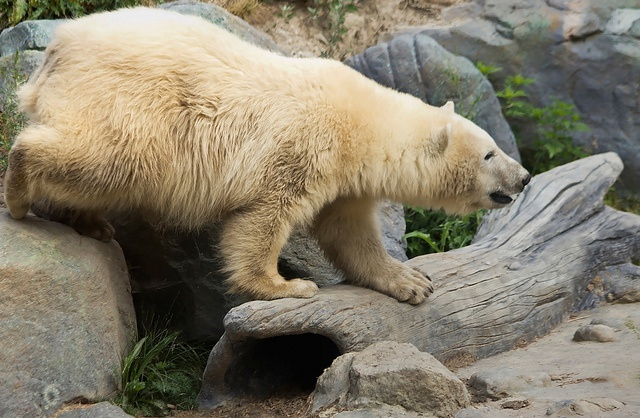Describe the objects in this image and their specific colors. I can see a bear in green, tan, and beige tones in this image. 